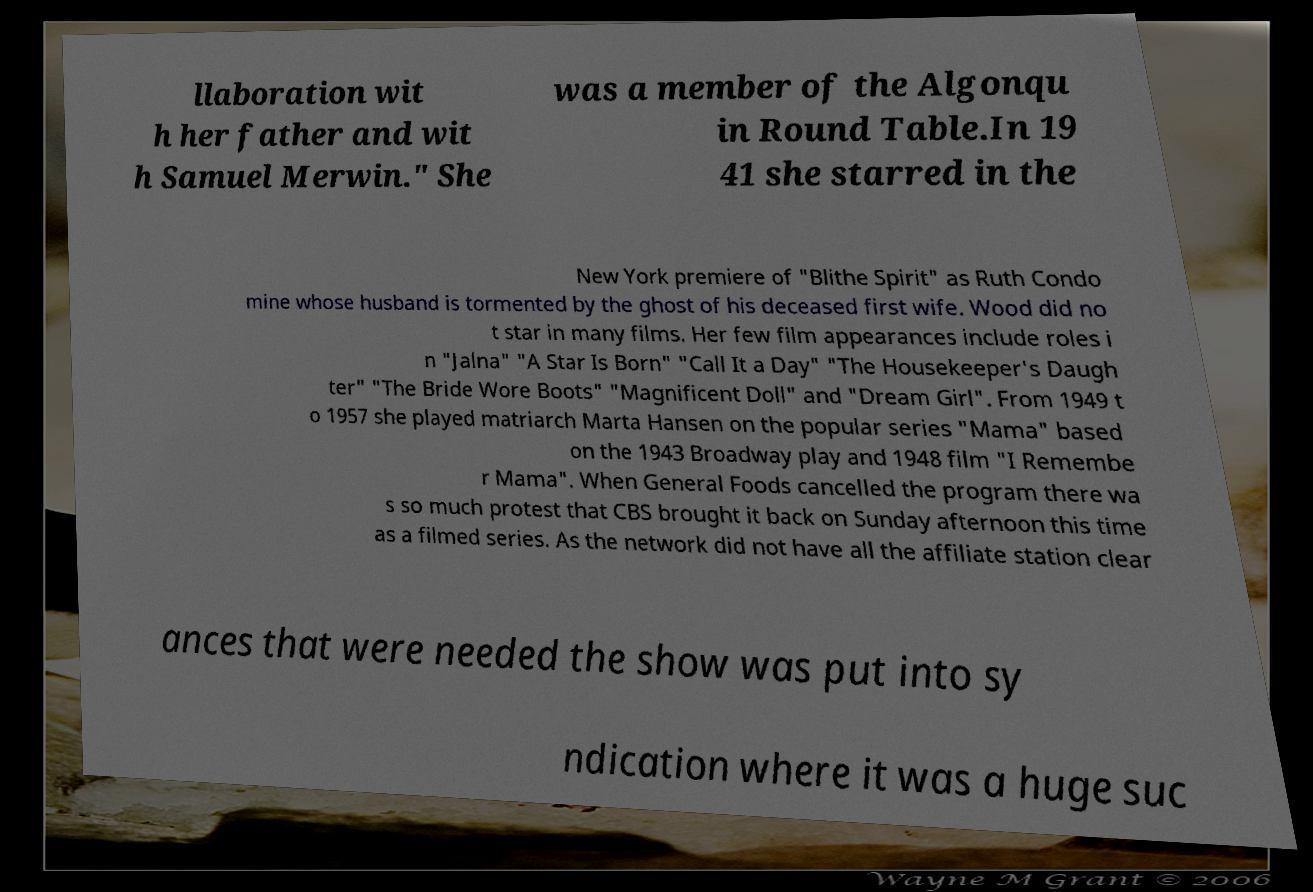Please identify and transcribe the text found in this image. llaboration wit h her father and wit h Samuel Merwin." She was a member of the Algonqu in Round Table.In 19 41 she starred in the New York premiere of "Blithe Spirit" as Ruth Condo mine whose husband is tormented by the ghost of his deceased first wife. Wood did no t star in many films. Her few film appearances include roles i n "Jalna" "A Star Is Born" "Call It a Day" "The Housekeeper's Daugh ter" "The Bride Wore Boots" "Magnificent Doll" and "Dream Girl". From 1949 t o 1957 she played matriarch Marta Hansen on the popular series "Mama" based on the 1943 Broadway play and 1948 film "I Remembe r Mama". When General Foods cancelled the program there wa s so much protest that CBS brought it back on Sunday afternoon this time as a filmed series. As the network did not have all the affiliate station clear ances that were needed the show was put into sy ndication where it was a huge suc 